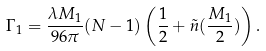<formula> <loc_0><loc_0><loc_500><loc_500>\Gamma _ { 1 } = \frac { \lambda M _ { 1 } } { 9 6 \pi } ( N - 1 ) \left ( \frac { 1 } { 2 } + \tilde { n } ( \frac { M _ { 1 } } 2 ) \right ) .</formula> 